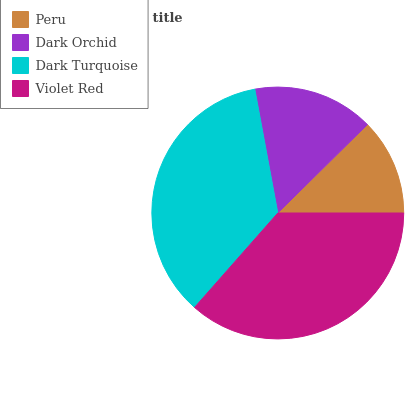Is Peru the minimum?
Answer yes or no. Yes. Is Violet Red the maximum?
Answer yes or no. Yes. Is Dark Orchid the minimum?
Answer yes or no. No. Is Dark Orchid the maximum?
Answer yes or no. No. Is Dark Orchid greater than Peru?
Answer yes or no. Yes. Is Peru less than Dark Orchid?
Answer yes or no. Yes. Is Peru greater than Dark Orchid?
Answer yes or no. No. Is Dark Orchid less than Peru?
Answer yes or no. No. Is Dark Turquoise the high median?
Answer yes or no. Yes. Is Dark Orchid the low median?
Answer yes or no. Yes. Is Violet Red the high median?
Answer yes or no. No. Is Violet Red the low median?
Answer yes or no. No. 